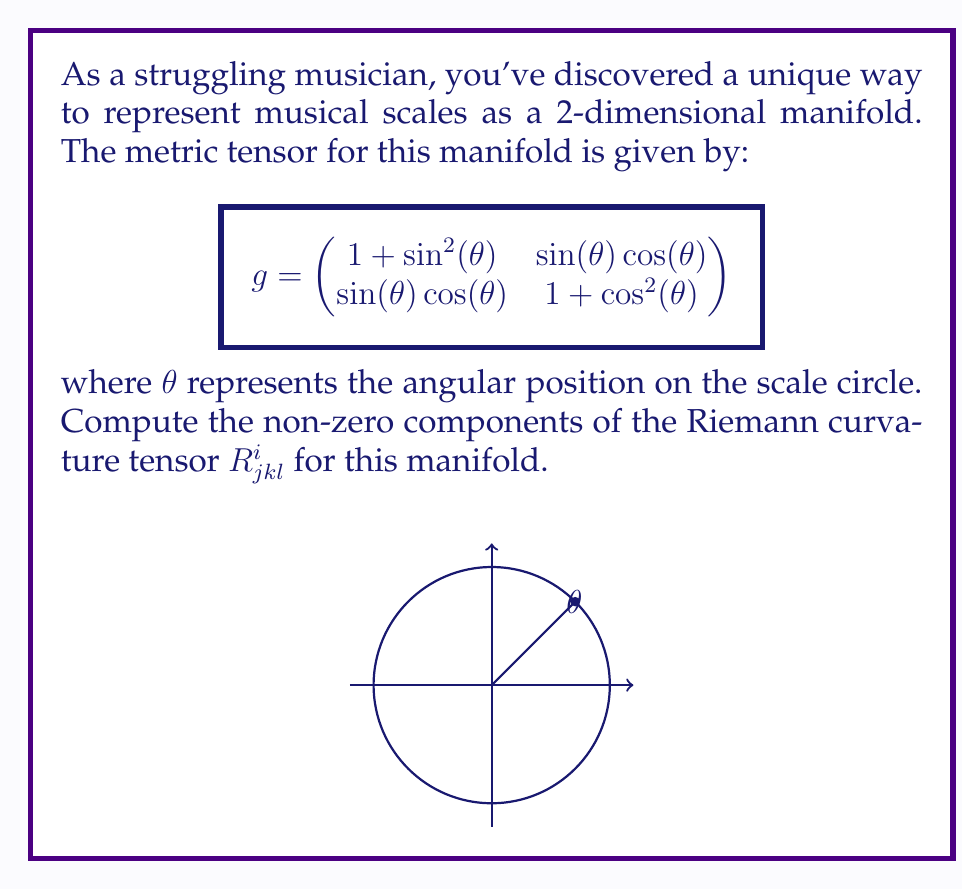Could you help me with this problem? To compute the Riemann curvature tensor, we'll follow these steps:

1) First, we need to calculate the Christoffel symbols $\Gamma^i_{jk}$:
   $$\Gamma^i_{jk} = \frac{1}{2}g^{im}(\partial_j g_{km} + \partial_k g_{jm} - \partial_m g_{jk})$$

2) The inverse metric tensor $g^{ij}$ is:
   $$g^{ij} = \frac{1}{2-\sin^2(\theta)-\cos^2(\theta)} \begin{pmatrix}
   1+\cos^2(\theta) & -\sin(\theta)\cos(\theta) \\
   -\sin(\theta)\cos(\theta) & 1+\sin^2(\theta)
   \end{pmatrix}$$

3) Calculating the non-zero Christoffel symbols:
   $$\Gamma^1_{12} = \Gamma^1_{21} = \frac{\cos(\theta)}{2-\sin^2(\theta)-\cos^2(\theta)}$$
   $$\Gamma^1_{22} = -\frac{\sin(\theta)(1+\cos^2(\theta))}{2-\sin^2(\theta)-\cos^2(\theta)}$$
   $$\Gamma^2_{11} = \frac{\sin(\theta)(1+\sin^2(\theta))}{2-\sin^2(\theta)-\cos^2(\theta)}$$
   $$\Gamma^2_{12} = \Gamma^2_{21} = -\frac{\sin(\theta)}{2-\sin^2(\theta)-\cos^2(\theta)}$$

4) Now we can compute the Riemann curvature tensor:
   $$R^i_{jkl} = \partial_k \Gamma^i_{jl} - \partial_l \Gamma^i_{jk} + \Gamma^m_{jl}\Gamma^i_{km} - \Gamma^m_{jk}\Gamma^i_{lm}$$

5) After calculation, we find that the only non-zero independent component is:
   $$R^1_{212} = -R^1_{221} = R^2_{121} = -R^2_{112} = \frac{1}{2-\sin^2(\theta)-\cos^2(\theta)}$$

6) All other components are either zero or can be derived from these using the symmetries of the Riemann tensor.
Answer: $R^1_{212} = -R^1_{221} = R^2_{121} = -R^2_{112} = \frac{1}{2-\sin^2(\theta)-\cos^2(\theta)}$ 